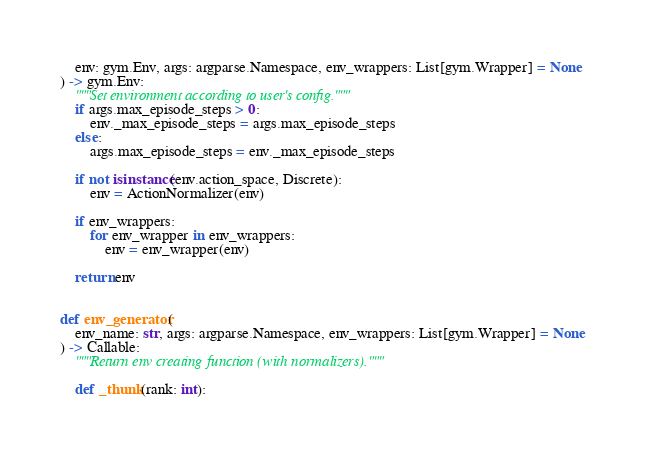Convert code to text. <code><loc_0><loc_0><loc_500><loc_500><_Python_>    env: gym.Env, args: argparse.Namespace, env_wrappers: List[gym.Wrapper] = None
) -> gym.Env:
    """Set environment according to user's config."""
    if args.max_episode_steps > 0:
        env._max_episode_steps = args.max_episode_steps
    else:
        args.max_episode_steps = env._max_episode_steps

    if not isinstance(env.action_space, Discrete):
        env = ActionNormalizer(env)

    if env_wrappers:
        for env_wrapper in env_wrappers:
            env = env_wrapper(env)

    return env


def env_generator(
    env_name: str, args: argparse.Namespace, env_wrappers: List[gym.Wrapper] = None
) -> Callable:
    """Return env creating function (with normalizers)."""

    def _thunk(rank: int):</code> 